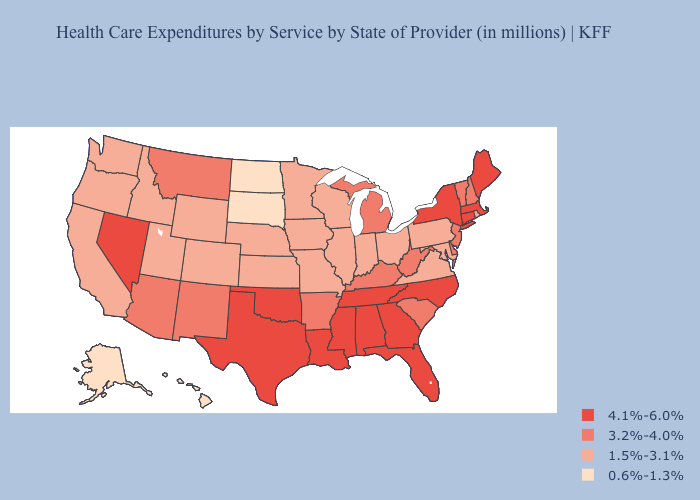Does Utah have the highest value in the USA?
Short answer required. No. Does the map have missing data?
Write a very short answer. No. Does New Jersey have the same value as Idaho?
Be succinct. No. Name the states that have a value in the range 3.2%-4.0%?
Be succinct. Arizona, Arkansas, Delaware, Kentucky, Michigan, Montana, New Hampshire, New Jersey, New Mexico, South Carolina, Vermont, West Virginia. Name the states that have a value in the range 3.2%-4.0%?
Write a very short answer. Arizona, Arkansas, Delaware, Kentucky, Michigan, Montana, New Hampshire, New Jersey, New Mexico, South Carolina, Vermont, West Virginia. What is the value of Iowa?
Answer briefly. 1.5%-3.1%. Which states have the highest value in the USA?
Quick response, please. Alabama, Connecticut, Florida, Georgia, Louisiana, Maine, Massachusetts, Mississippi, Nevada, New York, North Carolina, Oklahoma, Tennessee, Texas. What is the value of Oregon?
Give a very brief answer. 1.5%-3.1%. Is the legend a continuous bar?
Write a very short answer. No. Does Oregon have the lowest value in the USA?
Give a very brief answer. No. Among the states that border Nevada , which have the highest value?
Answer briefly. Arizona. Which states hav the highest value in the West?
Write a very short answer. Nevada. Name the states that have a value in the range 0.6%-1.3%?
Concise answer only. Alaska, Hawaii, North Dakota, South Dakota. What is the value of Iowa?
Keep it brief. 1.5%-3.1%. Name the states that have a value in the range 0.6%-1.3%?
Answer briefly. Alaska, Hawaii, North Dakota, South Dakota. 